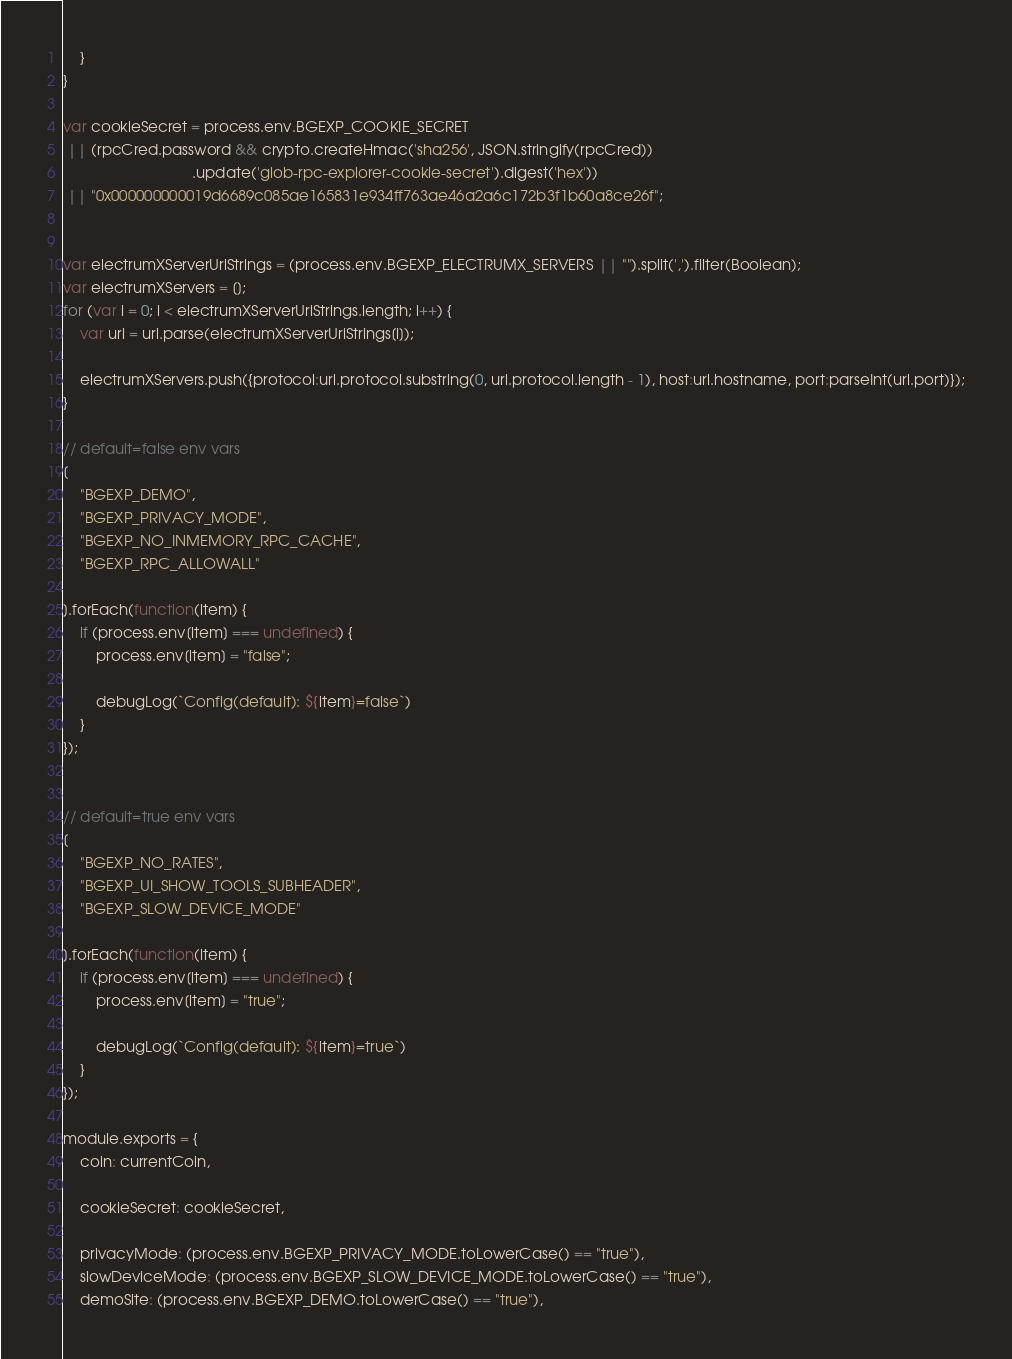Convert code to text. <code><loc_0><loc_0><loc_500><loc_500><_JavaScript_>	}
}

var cookieSecret = process.env.BGEXP_COOKIE_SECRET
 || (rpcCred.password && crypto.createHmac('sha256', JSON.stringify(rpcCred))
                               .update('glob-rpc-explorer-cookie-secret').digest('hex'))
 || "0x000000000019d6689c085ae165831e934ff763ae46a2a6c172b3f1b60a8ce26f";


var electrumXServerUriStrings = (process.env.BGEXP_ELECTRUMX_SERVERS || "").split(',').filter(Boolean);
var electrumXServers = [];
for (var i = 0; i < electrumXServerUriStrings.length; i++) {
	var uri = url.parse(electrumXServerUriStrings[i]);
	
	electrumXServers.push({protocol:uri.protocol.substring(0, uri.protocol.length - 1), host:uri.hostname, port:parseInt(uri.port)});
}

// default=false env vars
[
	"BGEXP_DEMO",
	"BGEXP_PRIVACY_MODE",
	"BGEXP_NO_INMEMORY_RPC_CACHE",
	"BGEXP_RPC_ALLOWALL"

].forEach(function(item) {
	if (process.env[item] === undefined) {
		process.env[item] = "false";

		debugLog(`Config(default): ${item}=false`)
	}
});


// default=true env vars
[
	"BGEXP_NO_RATES",
	"BGEXP_UI_SHOW_TOOLS_SUBHEADER",
	"BGEXP_SLOW_DEVICE_MODE"

].forEach(function(item) {
	if (process.env[item] === undefined) {
		process.env[item] = "true";

		debugLog(`Config(default): ${item}=true`)
	}
});

module.exports = {
	coin: currentCoin,

	cookieSecret: cookieSecret,

	privacyMode: (process.env.BGEXP_PRIVACY_MODE.toLowerCase() == "true"),
	slowDeviceMode: (process.env.BGEXP_SLOW_DEVICE_MODE.toLowerCase() == "true"),
	demoSite: (process.env.BGEXP_DEMO.toLowerCase() == "true"),</code> 